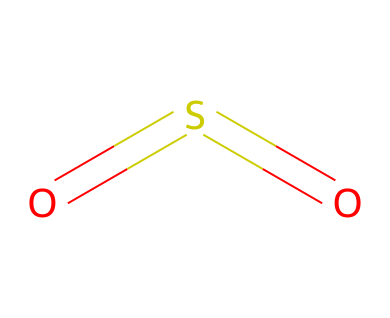What is the name of this chemical? The SMILES representation O=S=O corresponds to sulfur dioxide, which is a common air pollutant.
Answer: sulfur dioxide How many atoms are present in this molecule? The structure shows one sulfur atom (S) and two oxygen atoms (O). Therefore, the total number of atoms is three.
Answer: three What type of bonding is present in sulfur dioxide? The bonds between sulfur and oxygen in this molecule are double bonds, as indicated by the "=" signs in the SMILES representation.
Answer: double bonds How many double bonds are in sulfur dioxide? The SMILES notation indicates that there are two double bonds (one between each sulfur and oxygen) in the sulfur dioxide molecule.
Answer: two What is the oxidation state of sulfur in this compound? Sulfur in sulfur dioxide has an oxidation state of +4 because each oxygen contributes -2, leading to the equation: x + 2(-2) = 0. Solving this gives x = +4 for sulfur.
Answer: +4 Is sulfur dioxide a Lewis acid or a Lewis base? Sulfur dioxide can act as a Lewis acid because it can accept a pair of electrons due to the presence of an empty d-orbital in sulfur.
Answer: Lewis acid What effect does sulfur dioxide have on respiratory health? Sulfur dioxide is known to irritate the respiratory tract, causing complications for individuals with respiratory issues like asthma or COPD.
Answer: irritation 